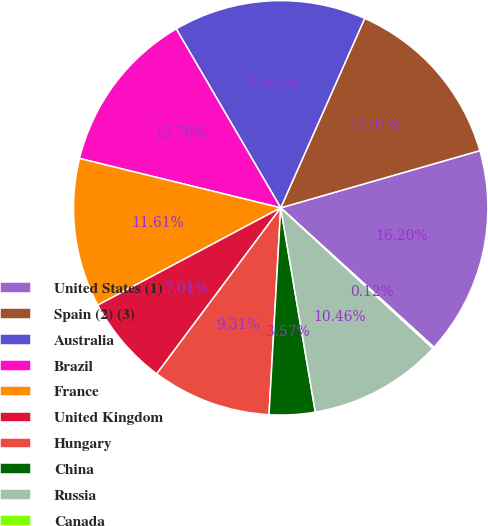Convert chart. <chart><loc_0><loc_0><loc_500><loc_500><pie_chart><fcel>United States (1)<fcel>Spain (2) (3)<fcel>Australia<fcel>Brazil<fcel>France<fcel>United Kingdom<fcel>Hungary<fcel>China<fcel>Russia<fcel>Canada<nl><fcel>16.2%<fcel>13.91%<fcel>15.05%<fcel>12.76%<fcel>11.61%<fcel>7.01%<fcel>9.31%<fcel>3.57%<fcel>10.46%<fcel>0.12%<nl></chart> 